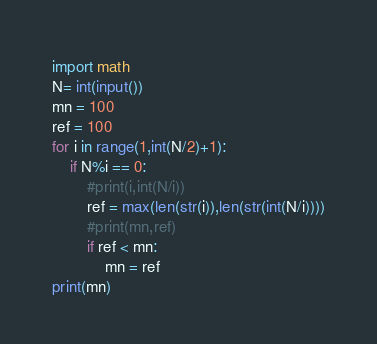Convert code to text. <code><loc_0><loc_0><loc_500><loc_500><_Python_>import math
N= int(input())
mn = 100
ref = 100
for i in range(1,int(N/2)+1):
    if N%i == 0:
        #print(i,int(N/i))
        ref = max(len(str(i)),len(str(int(N/i))))
        #print(mn,ref)
        if ref < mn:
            mn = ref
print(mn)</code> 